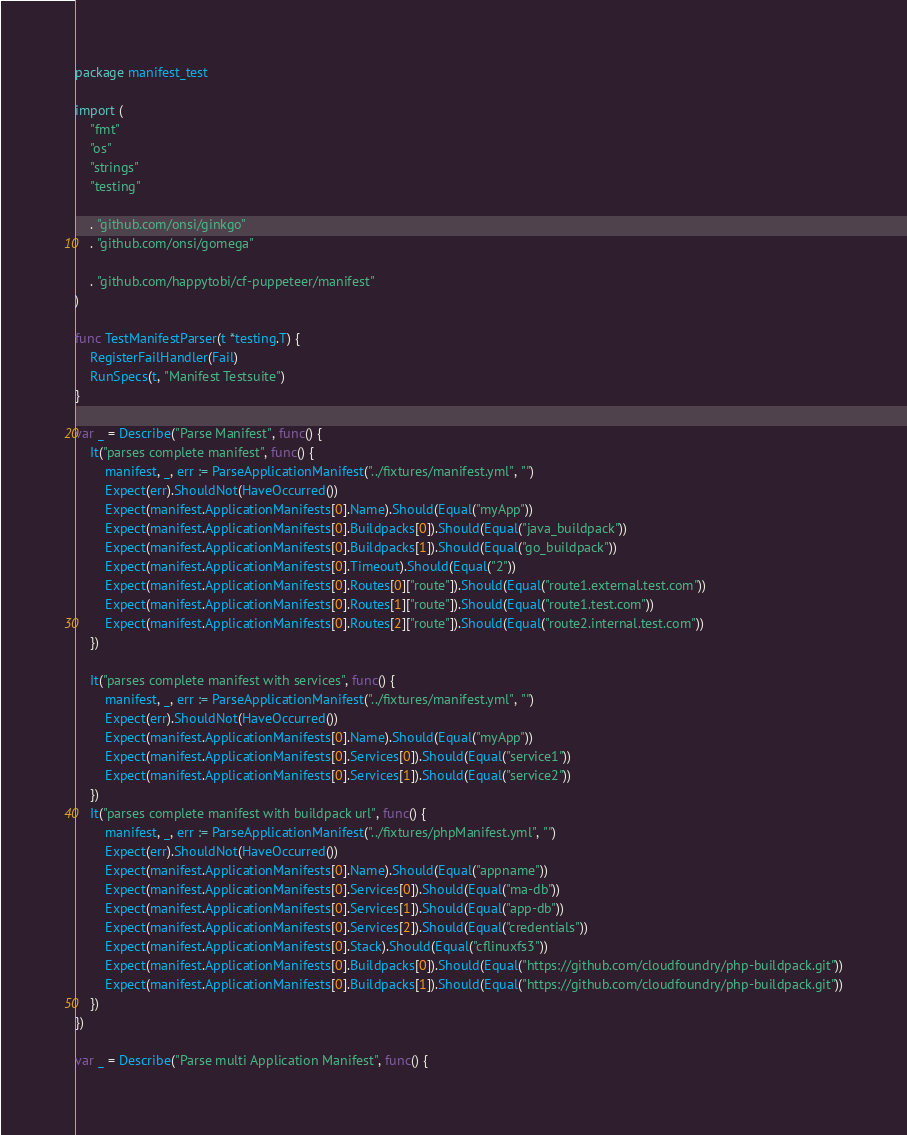Convert code to text. <code><loc_0><loc_0><loc_500><loc_500><_Go_>package manifest_test

import (
	"fmt"
	"os"
	"strings"
	"testing"

	. "github.com/onsi/ginkgo"
	. "github.com/onsi/gomega"

	. "github.com/happytobi/cf-puppeteer/manifest"
)

func TestManifestParser(t *testing.T) {
	RegisterFailHandler(Fail)
	RunSpecs(t, "Manifest Testsuite")
}

var _ = Describe("Parse Manifest", func() {
	It("parses complete manifest", func() {
		manifest, _, err := ParseApplicationManifest("../fixtures/manifest.yml", "")
		Expect(err).ShouldNot(HaveOccurred())
		Expect(manifest.ApplicationManifests[0].Name).Should(Equal("myApp"))
		Expect(manifest.ApplicationManifests[0].Buildpacks[0]).Should(Equal("java_buildpack"))
		Expect(manifest.ApplicationManifests[0].Buildpacks[1]).Should(Equal("go_buildpack"))
		Expect(manifest.ApplicationManifests[0].Timeout).Should(Equal("2"))
		Expect(manifest.ApplicationManifests[0].Routes[0]["route"]).Should(Equal("route1.external.test.com"))
		Expect(manifest.ApplicationManifests[0].Routes[1]["route"]).Should(Equal("route1.test.com"))
		Expect(manifest.ApplicationManifests[0].Routes[2]["route"]).Should(Equal("route2.internal.test.com"))
	})

	It("parses complete manifest with services", func() {
		manifest, _, err := ParseApplicationManifest("../fixtures/manifest.yml", "")
		Expect(err).ShouldNot(HaveOccurred())
		Expect(manifest.ApplicationManifests[0].Name).Should(Equal("myApp"))
		Expect(manifest.ApplicationManifests[0].Services[0]).Should(Equal("service1"))
		Expect(manifest.ApplicationManifests[0].Services[1]).Should(Equal("service2"))
	})
	It("parses complete manifest with buildpack url", func() {
		manifest, _, err := ParseApplicationManifest("../fixtures/phpManifest.yml", "")
		Expect(err).ShouldNot(HaveOccurred())
		Expect(manifest.ApplicationManifests[0].Name).Should(Equal("appname"))
		Expect(manifest.ApplicationManifests[0].Services[0]).Should(Equal("ma-db"))
		Expect(manifest.ApplicationManifests[0].Services[1]).Should(Equal("app-db"))
		Expect(manifest.ApplicationManifests[0].Services[2]).Should(Equal("credentials"))
		Expect(manifest.ApplicationManifests[0].Stack).Should(Equal("cflinuxfs3"))
		Expect(manifest.ApplicationManifests[0].Buildpacks[0]).Should(Equal("https://github.com/cloudfoundry/php-buildpack.git"))
		Expect(manifest.ApplicationManifests[0].Buildpacks[1]).Should(Equal("https://github.com/cloudfoundry/php-buildpack.git"))
	})
})

var _ = Describe("Parse multi Application Manifest", func() {</code> 